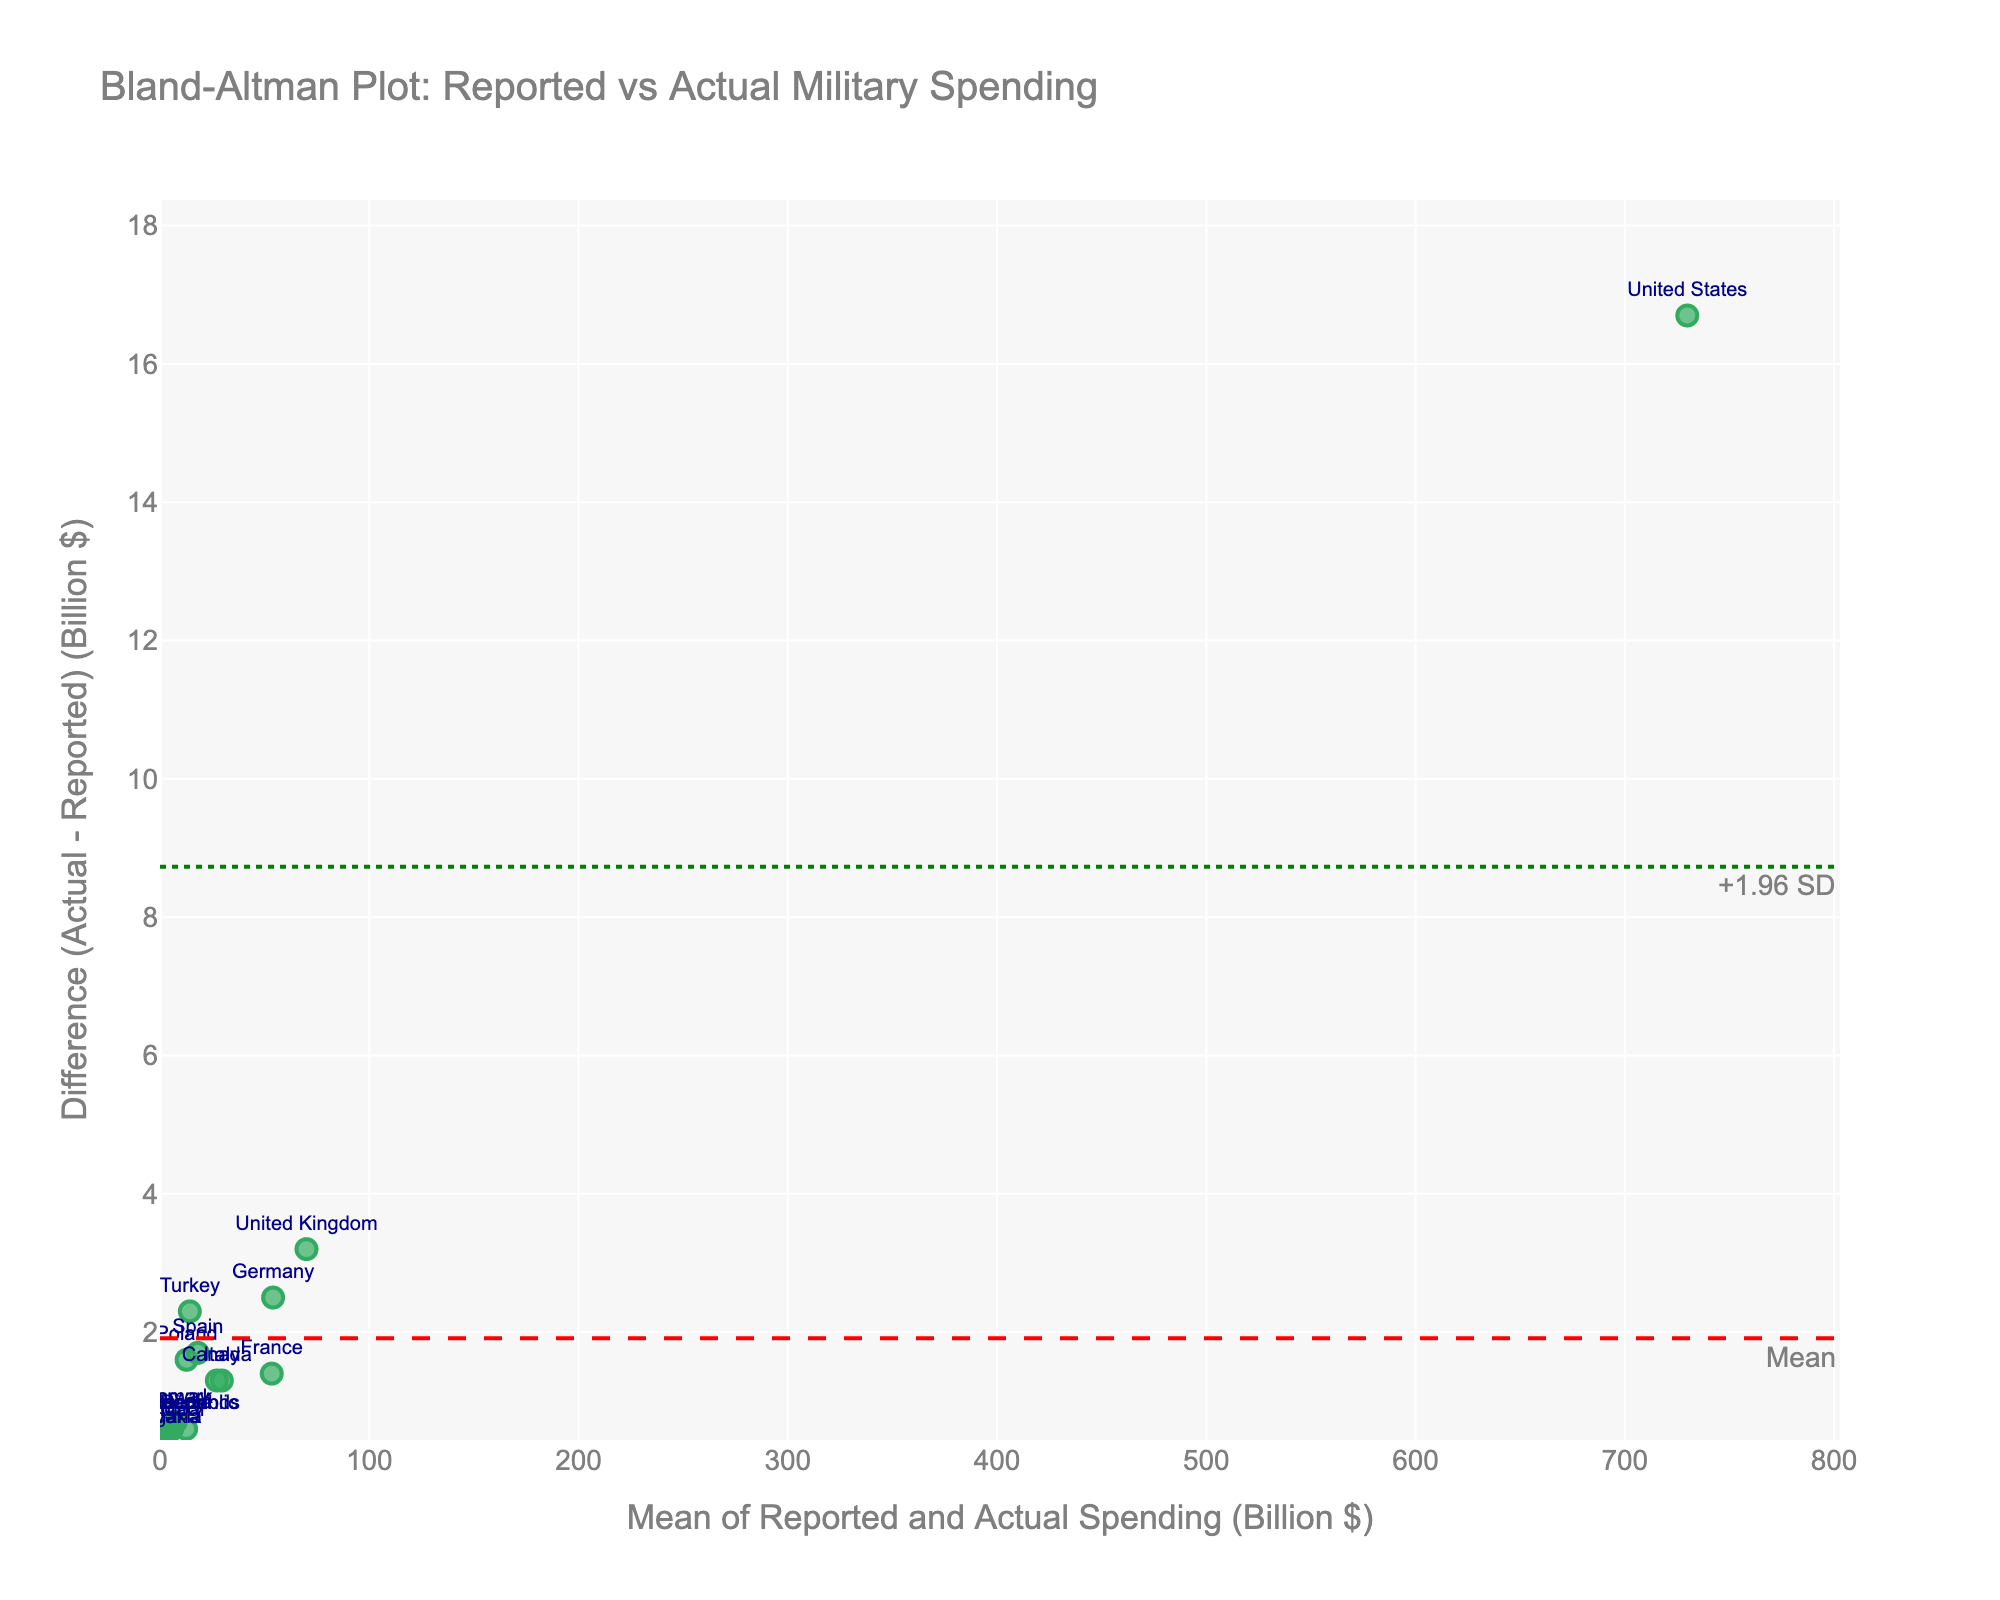How many data points are displayed in the plot? The plot should have one data point for each NATO country listed in the provided data. Count the number of NATO countries in the dataset.
Answer: 20 What does the y-axis represent in the plot? The y-axis of a Bland-Altman plot represents the difference between the actual and reported military spending.
Answer: Difference (Actual - Reported) (Billion $) What is the title of the plot? Look at the top of the plot where the title is typically displayed.
Answer: Bland-Altman Plot: Reported vs Actual Military Spending Which country has the largest positive difference between actual and reported military spending? Locate the data point with the highest value on the y-axis (positive difference) and refer to its label.
Answer: Turkey What is the mean difference between actual and reported spending, and what color is this line indicated in? Find the dashed horizontal line representing the mean difference. Its color and annotation will indicate this.
Answer: +1.96 SD, Green What are the upper and lower limits of agreement on the plot? Locate the two dotted horizontal lines above and below the mean difference line. These are the limits of agreement.
Answer: Upper: +1.96 SD, Lower: -1.96 SD Which country has a mean spending value closest to 60 billion dollars based on the plot? Identify the data point closest to the x-axis value of 60 billion dollars, which shows the mean of reported and actual spending.
Answer: France Are there any countries where the reported spending is higher than the actual spending? Which ones? Find any data points that are below the horizontal line of y=0 (where Differences are negative) and refer to their labels.
Answer: Canada, Denmark, Belgium, Romania, Portugal, Czech Republic, Hungary, Slovakia, Bulgaria What does a data point above the mean difference line indicate in this plot? In a Bland-Altman plot, a data point above the mean difference line indicates that the actual spending is higher than the reported spending for that country.
Answer: Actual spending is higher than reported Which country lies nearest to the mean difference line? Identify the data point that is nearest to the dashed horizontal line representing the mean difference, and refer to its label.
Answer: Netherlands 